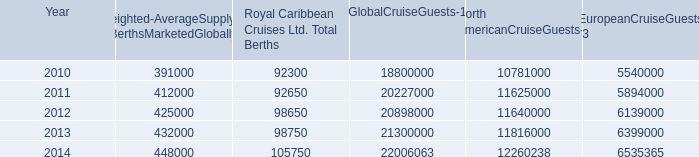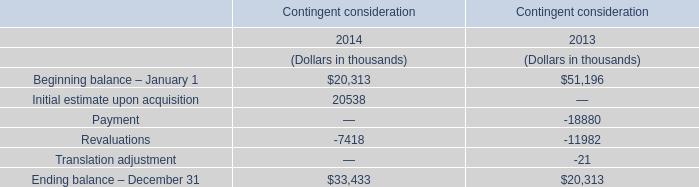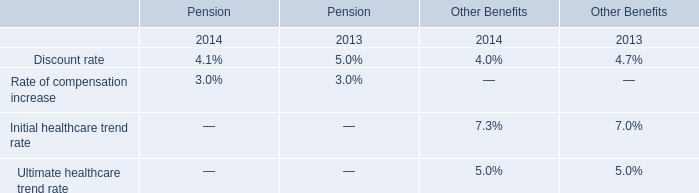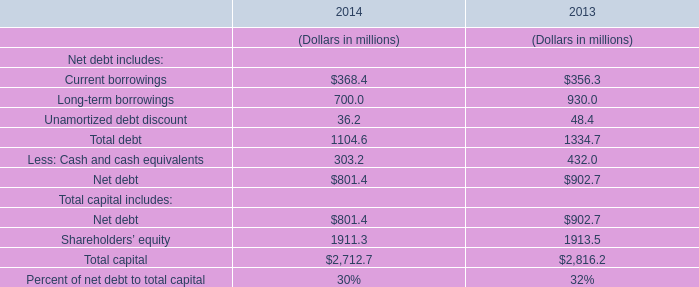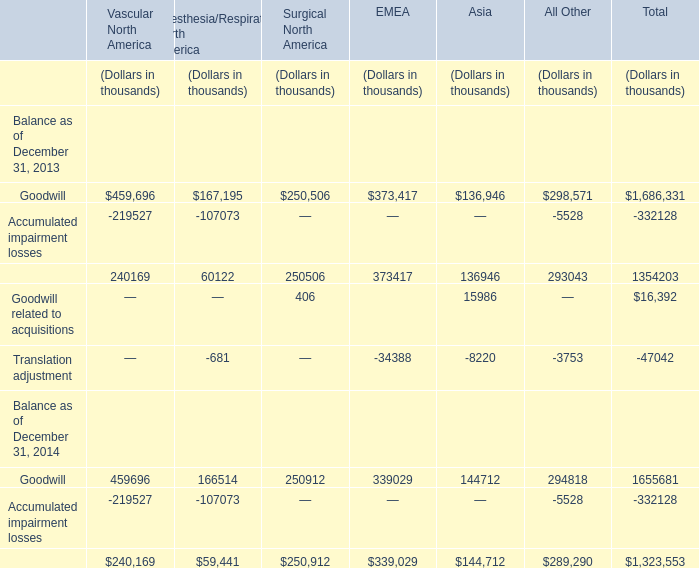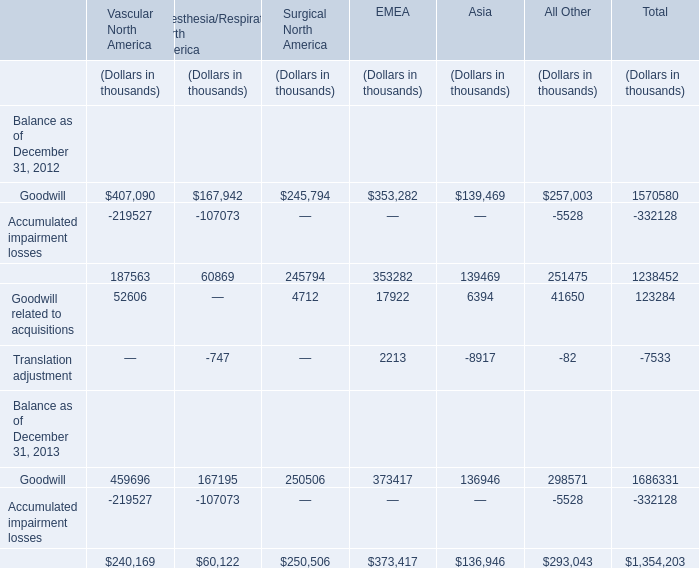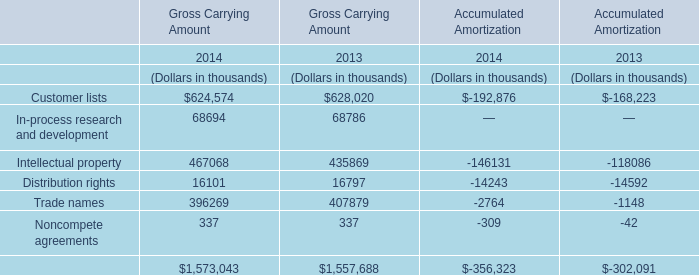What was the average of the Accumulated impairment losses in the years where Total revenues is positive? (in thousand) 
Computations: ((-332128 - 332128) / 2)
Answer: -332128.0. 